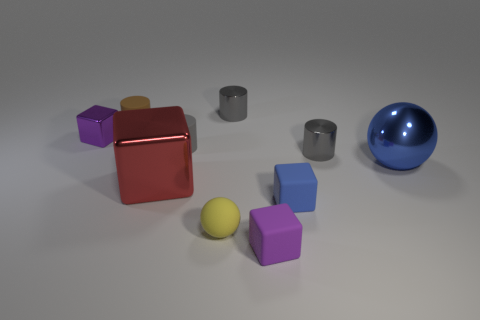How many gray cylinders must be subtracted to get 1 gray cylinders? 2 Subtract all cyan balls. How many gray cylinders are left? 3 Subtract 1 blocks. How many blocks are left? 3 Subtract all cylinders. How many objects are left? 6 Add 3 small yellow things. How many small yellow things are left? 4 Add 6 brown matte cylinders. How many brown matte cylinders exist? 7 Subtract 0 brown balls. How many objects are left? 10 Subtract all yellow spheres. Subtract all tiny yellow matte objects. How many objects are left? 8 